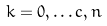<formula> <loc_0><loc_0><loc_500><loc_500>k = 0 , \dots c , n</formula> 